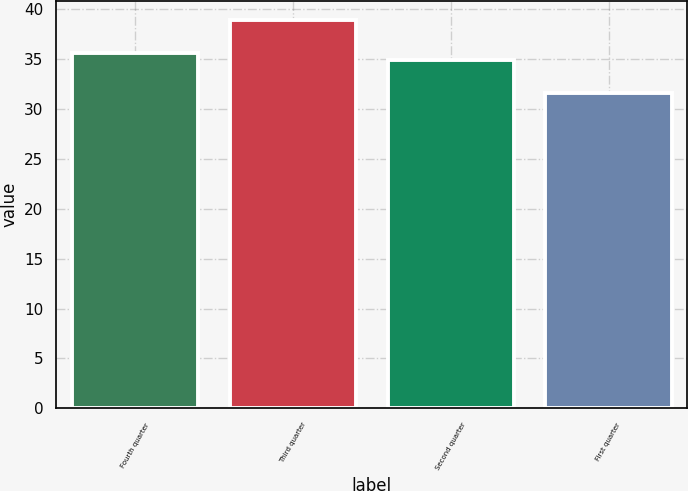<chart> <loc_0><loc_0><loc_500><loc_500><bar_chart><fcel>Fourth quarter<fcel>Third quarter<fcel>Second quarter<fcel>First quarter<nl><fcel>35.67<fcel>38.9<fcel>34.94<fcel>31.61<nl></chart> 